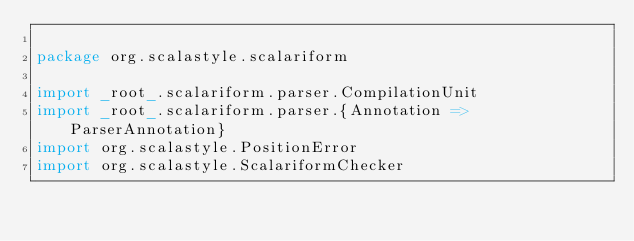Convert code to text. <code><loc_0><loc_0><loc_500><loc_500><_Scala_>
package org.scalastyle.scalariform

import _root_.scalariform.parser.CompilationUnit
import _root_.scalariform.parser.{Annotation => ParserAnnotation}
import org.scalastyle.PositionError
import org.scalastyle.ScalariformChecker</code> 